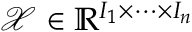<formula> <loc_0><loc_0><loc_500><loc_500>\mathcal { X } \in \mathbb { R } ^ { I _ { 1 } \times \dots \times I _ { n } }</formula> 